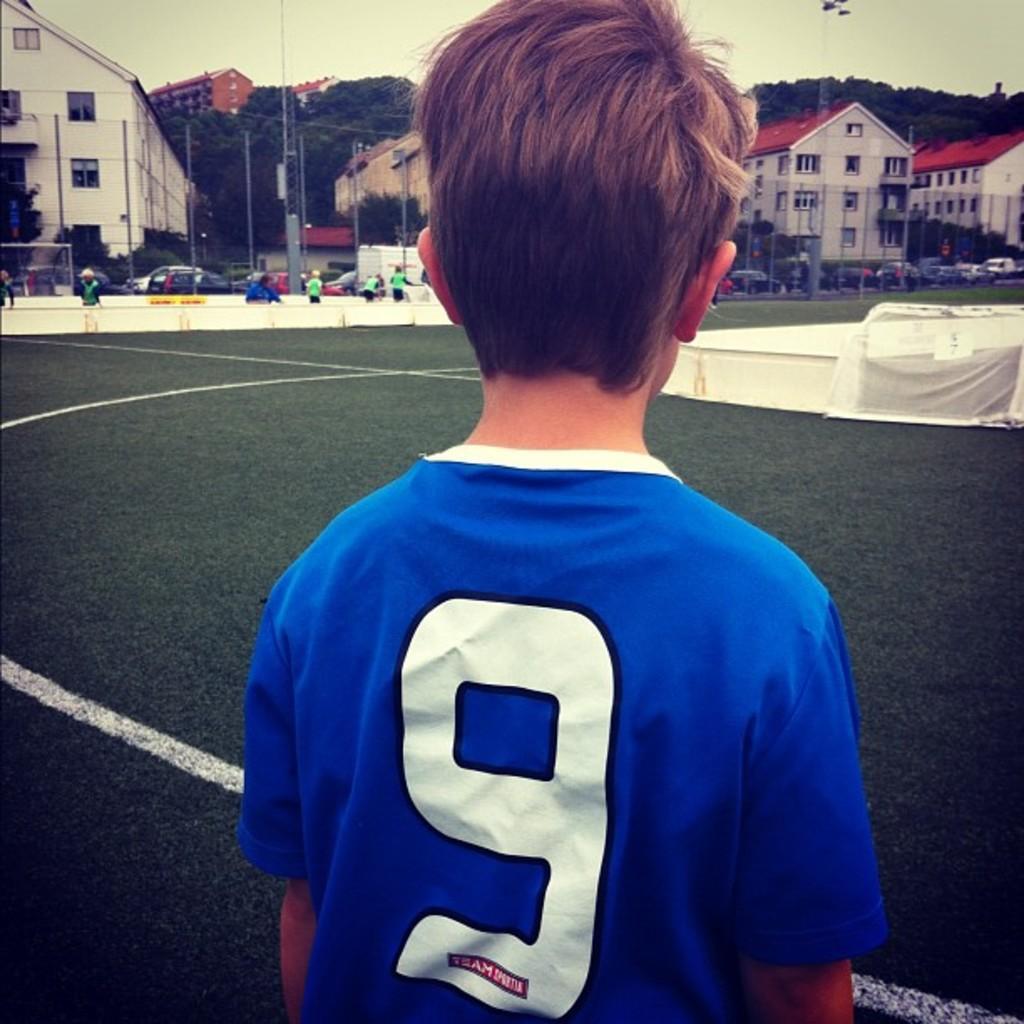Describe this image in one or two sentences. In this picture there is a boy wearing blue color t- shirt, standing and looking the football ground. Behind there is a fencing grill and some roof top houses. 